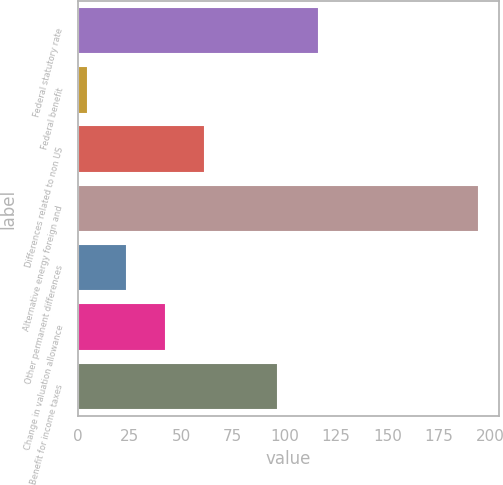Convert chart. <chart><loc_0><loc_0><loc_500><loc_500><bar_chart><fcel>Federal statutory rate<fcel>Federal benefit<fcel>Differences related to non US<fcel>Alternative energy foreign and<fcel>Other permanent differences<fcel>Change in valuation allowance<fcel>Benefit for income taxes<nl><fcel>116.7<fcel>4.5<fcel>61.47<fcel>194.4<fcel>23.49<fcel>42.48<fcel>96.7<nl></chart> 